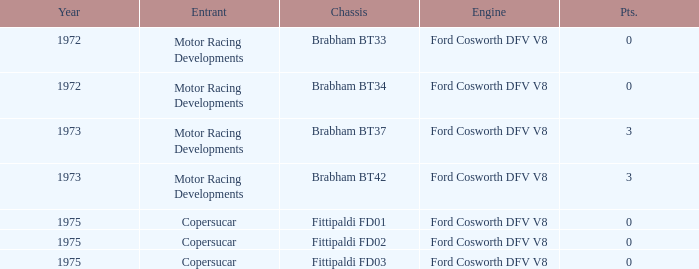Which chassis is more recent than 1972 and has more than 0 Pts. ? Brabham BT37, Brabham BT42. 